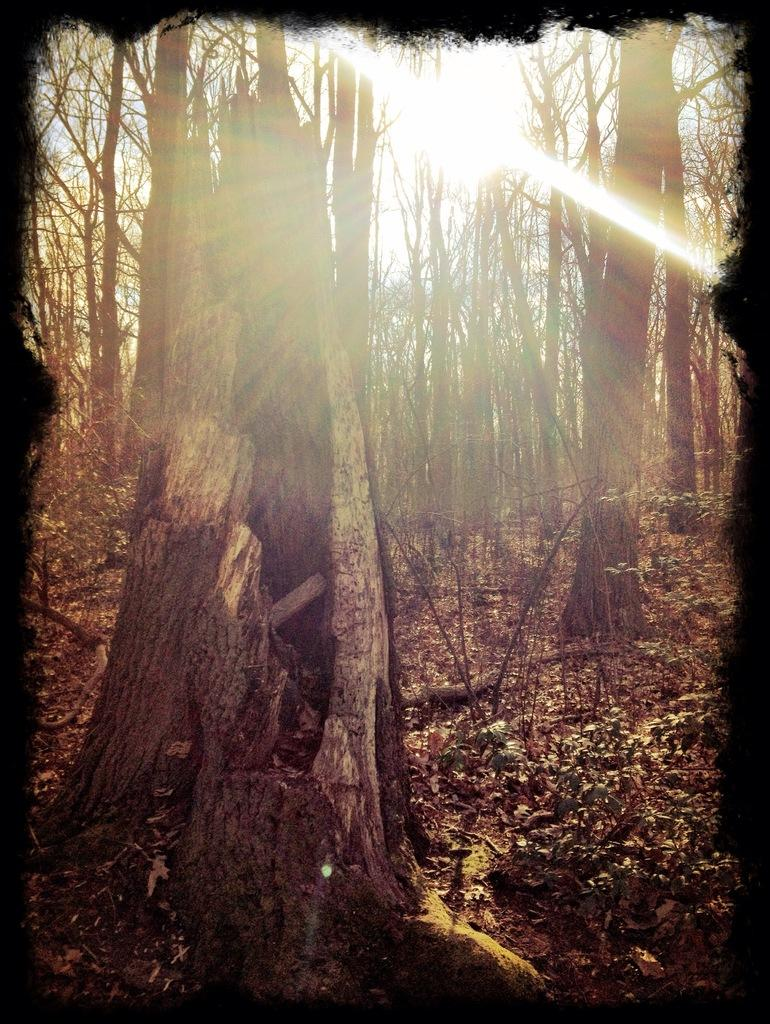What is covering the ground in the image? There are dry leaves on the ground in the image. What type of vegetation can be seen in the image? There are trees in the image. What is the source of light in the image? There is sunlight in the image. What type of connection can be seen between the trees in the image? There is no specific connection between the trees mentioned in the image. What is the stem of the tree in the image? The provided facts do not mention a tree with a stem, only the presence of trees in general. 